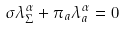<formula> <loc_0><loc_0><loc_500><loc_500>\sigma \lambda ^ { \alpha } _ { \Sigma } + \pi _ { a } \lambda ^ { \alpha } _ { a } = 0</formula> 